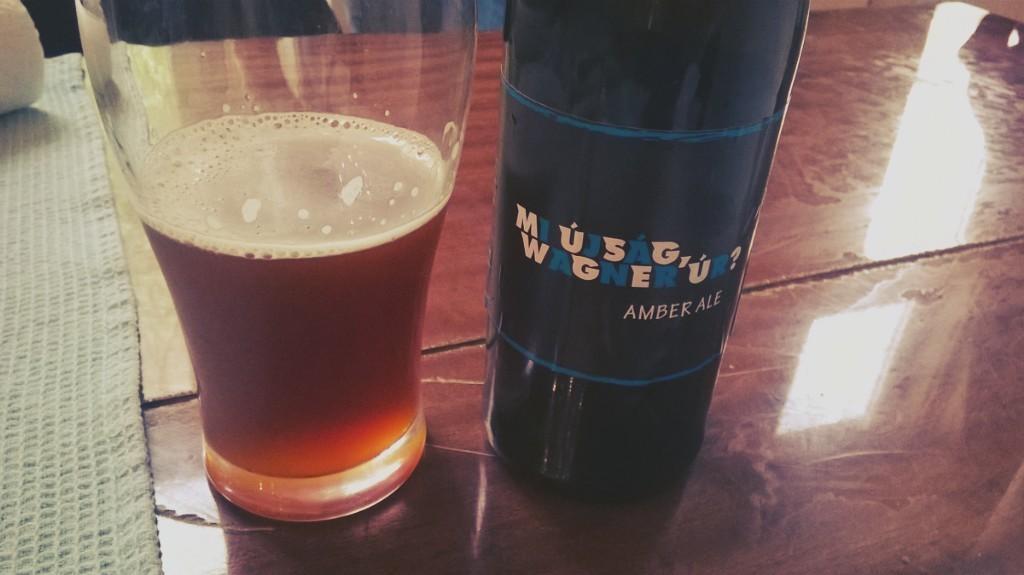What kind of ale is this bottle?
Keep it short and to the point. Amber. 